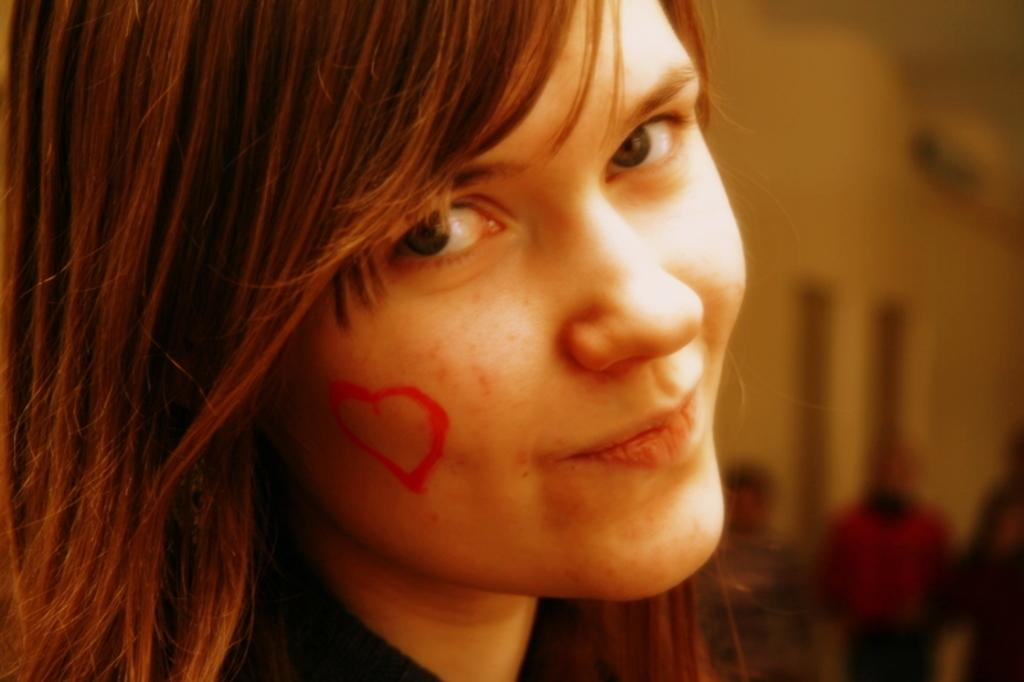What is the main subject of the image? The main subject of the image is a woman. Can you describe a unique feature of the woman in the image? The woman has a heart-shaped mark on her cheek. What type of chicken is present in the image? There is no chicken present in the image. What is the woman protesting about in the image? There is no indication in the image that the woman is protesting about anything. 